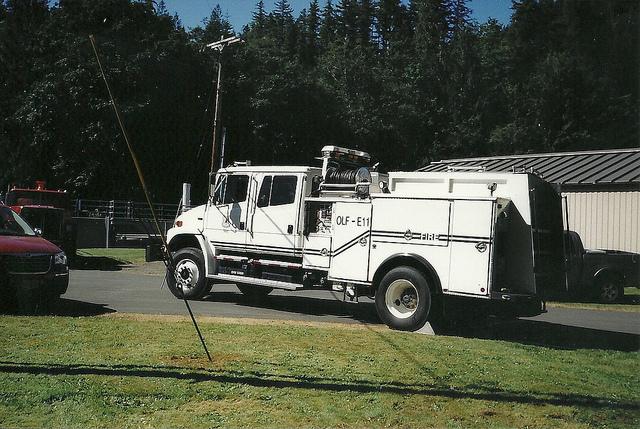Is this a limousine?
Be succinct. No. Is the truck driving on a road?
Quick response, please. Yes. Is it raining on the truck?
Write a very short answer. No. What is the truck in front doing?
Give a very brief answer. Parked. What color is the truck body?
Give a very brief answer. White. What are the letters and numbers on the truck?
Give a very brief answer. Olf-e11. 